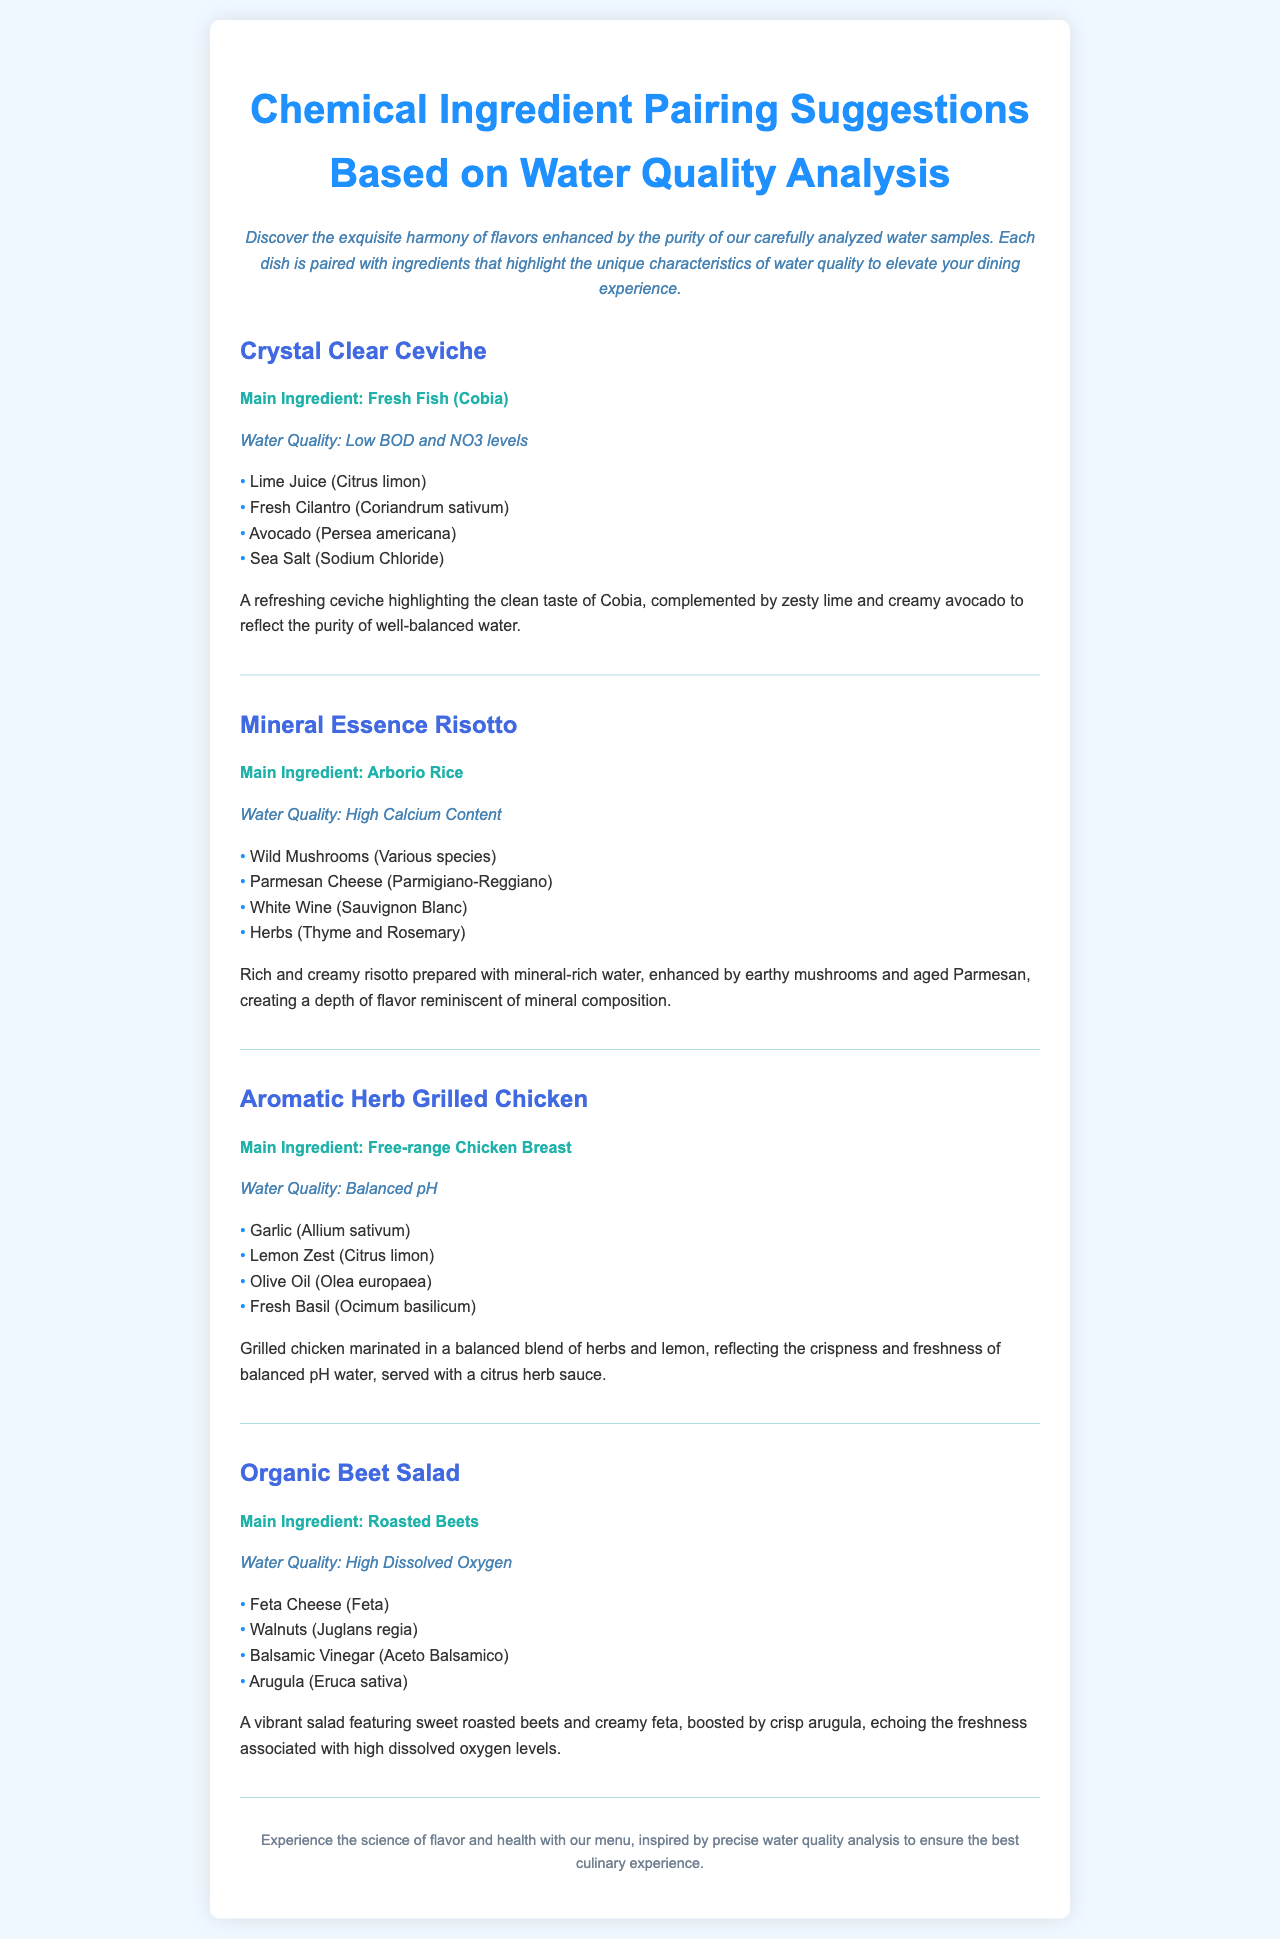What is the main ingredient of the Crystal Clear Ceviche? The main ingredient for the Crystal Clear Ceviche is specified in the document as Fresh Fish (Cobia).
Answer: Fresh Fish (Cobia) What is the water quality for the Mineral Essence Risotto? The document states that the water quality for the Mineral Essence Risotto is described as High Calcium Content.
Answer: High Calcium Content Which ingredient is paired with the Organic Beet Salad? The document lists Feta Cheese as one of the ingredients paired with the Organic Beet Salad.
Answer: Feta Cheese What flavor does the Aromatic Herb Grilled Chicken reflect? The description highlights that the Aromatic Herb Grilled Chicken reflects the crispness and freshness of balanced pH water.
Answer: Crispness and freshness How many dishes are featured in the menu? The document lists a total of four dishes in the menu, corresponding to the headings provided.
Answer: Four What type of water quality is associated with the Organic Beet Salad? The water quality stated for the Organic Beet Salad is High Dissolved Oxygen.
Answer: High Dissolved Oxygen What is the primary benefit suggested by the menu items? The menu emphasizes the benefit of flavor enhancement based on carefully analyzed water samples, as noted in the introductory description.
Answer: Flavor enhancement What herb is used in the marinade of the Aromatic Herb Grilled Chicken? Fresh Basil is mentioned as one of the herbs used in the marinade of the Aromatic Herb Grilled Chicken.
Answer: Fresh Basil What dish highlights the clean taste of its main ingredient? The document states that the Crystal Clear Ceviche highlights the clean taste of its main ingredient, Cobia.
Answer: Crystal Clear Ceviche 